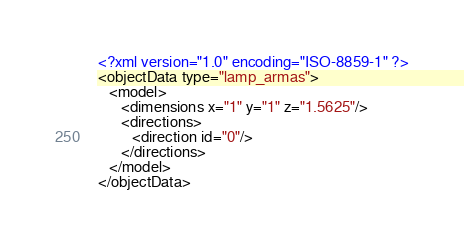Convert code to text. <code><loc_0><loc_0><loc_500><loc_500><_XML_><?xml version="1.0" encoding="ISO-8859-1" ?>
<objectData type="lamp_armas">
   <model>
      <dimensions x="1" y="1" z="1.5625"/>
      <directions>
         <direction id="0"/>
      </directions>
   </model>
</objectData>
</code> 